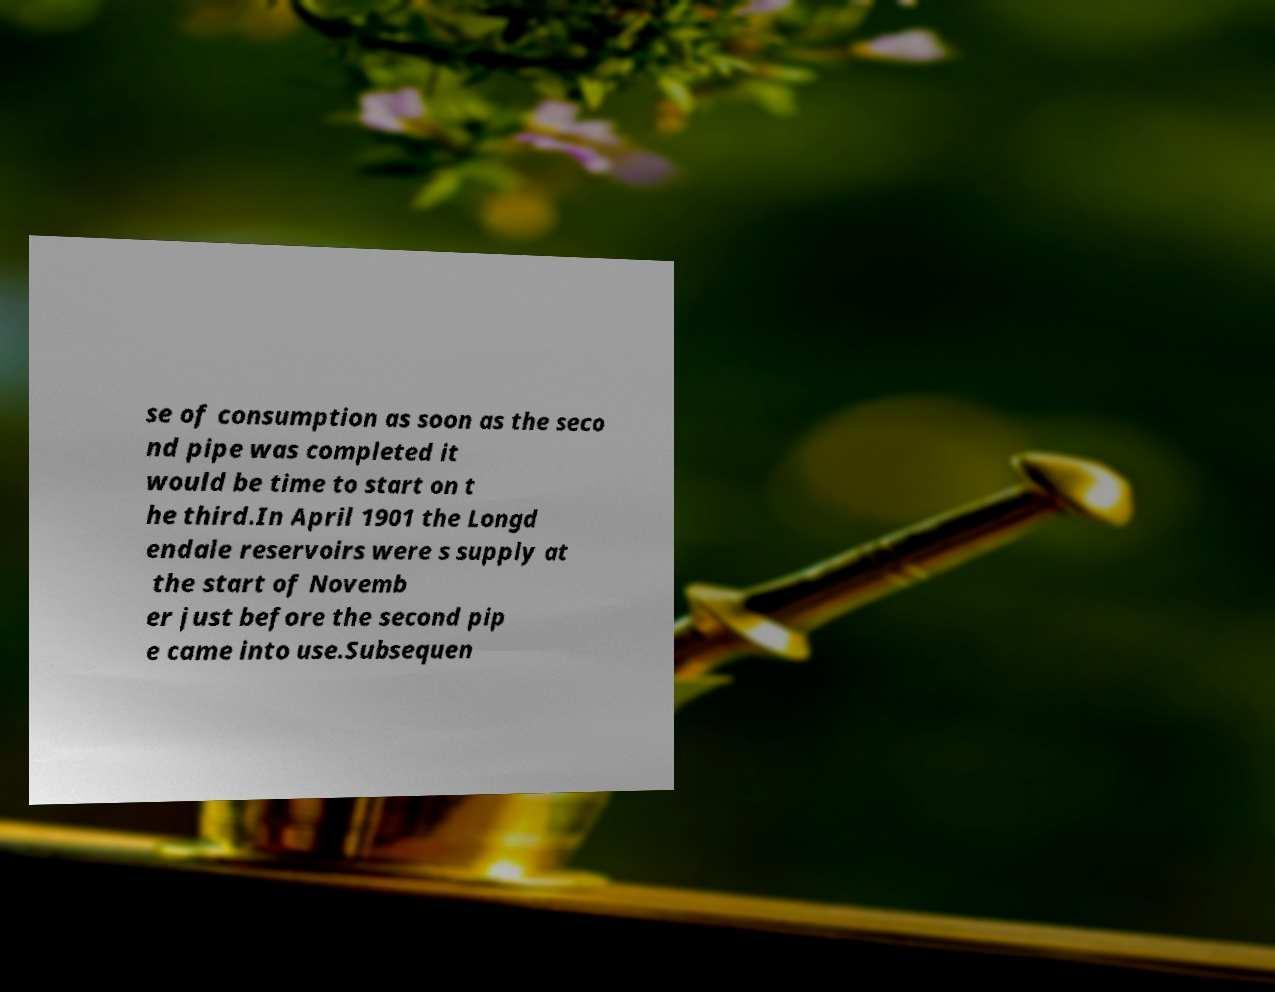For documentation purposes, I need the text within this image transcribed. Could you provide that? se of consumption as soon as the seco nd pipe was completed it would be time to start on t he third.In April 1901 the Longd endale reservoirs were s supply at the start of Novemb er just before the second pip e came into use.Subsequen 